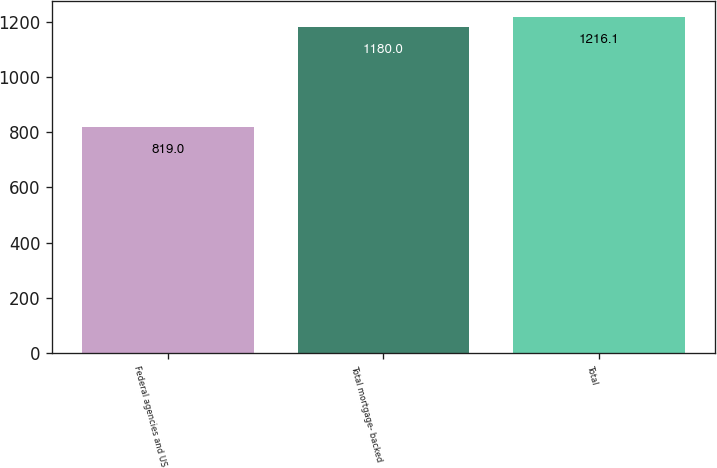<chart> <loc_0><loc_0><loc_500><loc_500><bar_chart><fcel>Federal agencies and US<fcel>Total mortgage- backed<fcel>Total<nl><fcel>819<fcel>1180<fcel>1216.1<nl></chart> 